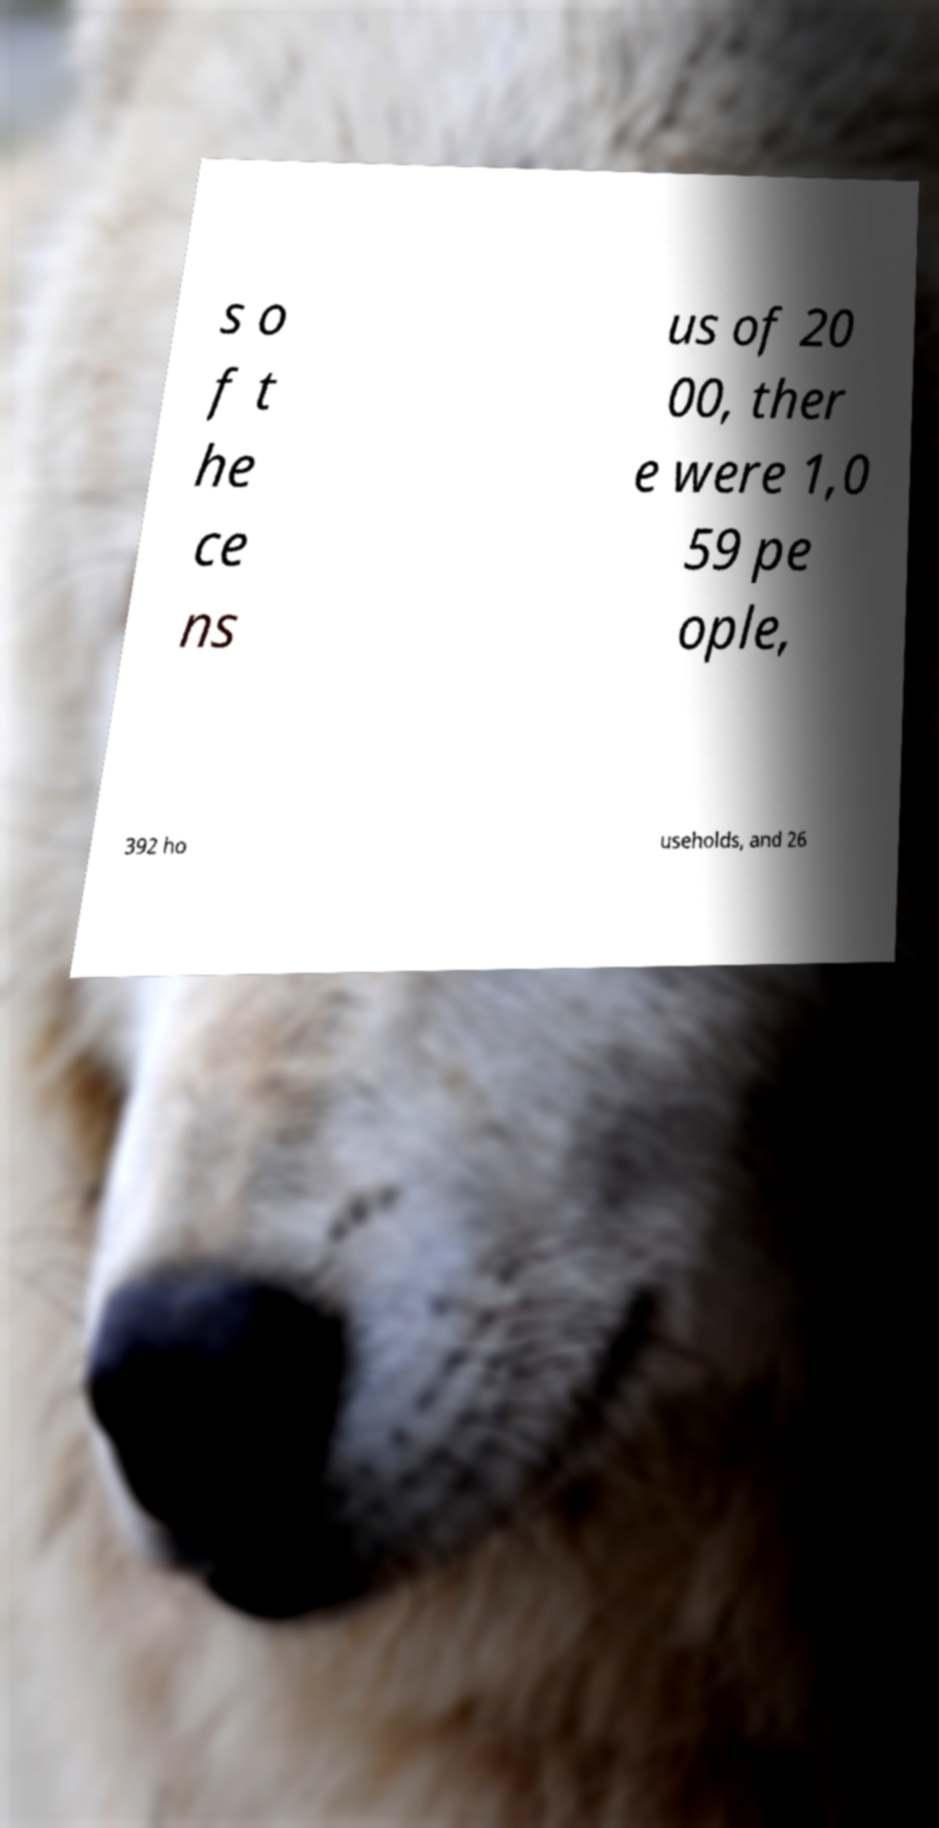Could you assist in decoding the text presented in this image and type it out clearly? s o f t he ce ns us of 20 00, ther e were 1,0 59 pe ople, 392 ho useholds, and 26 